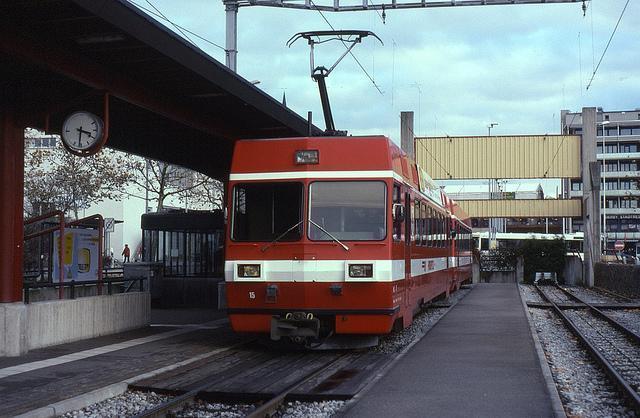How many toy mice have a sign?
Give a very brief answer. 0. 